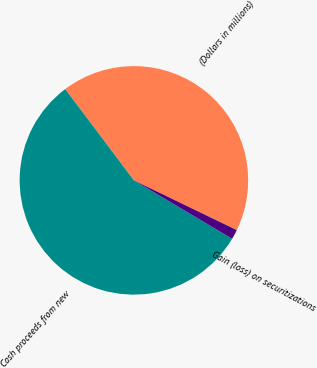<chart> <loc_0><loc_0><loc_500><loc_500><pie_chart><fcel>(Dollars in millions)<fcel>Cash proceeds from new<fcel>Gain (loss) on securitizations<nl><fcel>42.44%<fcel>56.19%<fcel>1.37%<nl></chart> 